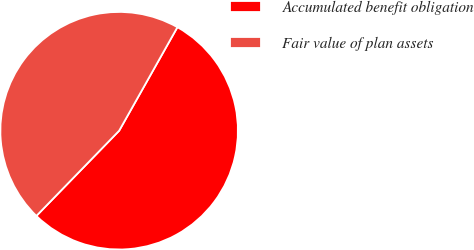Convert chart to OTSL. <chart><loc_0><loc_0><loc_500><loc_500><pie_chart><fcel>Accumulated benefit obligation<fcel>Fair value of plan assets<nl><fcel>54.11%<fcel>45.89%<nl></chart> 